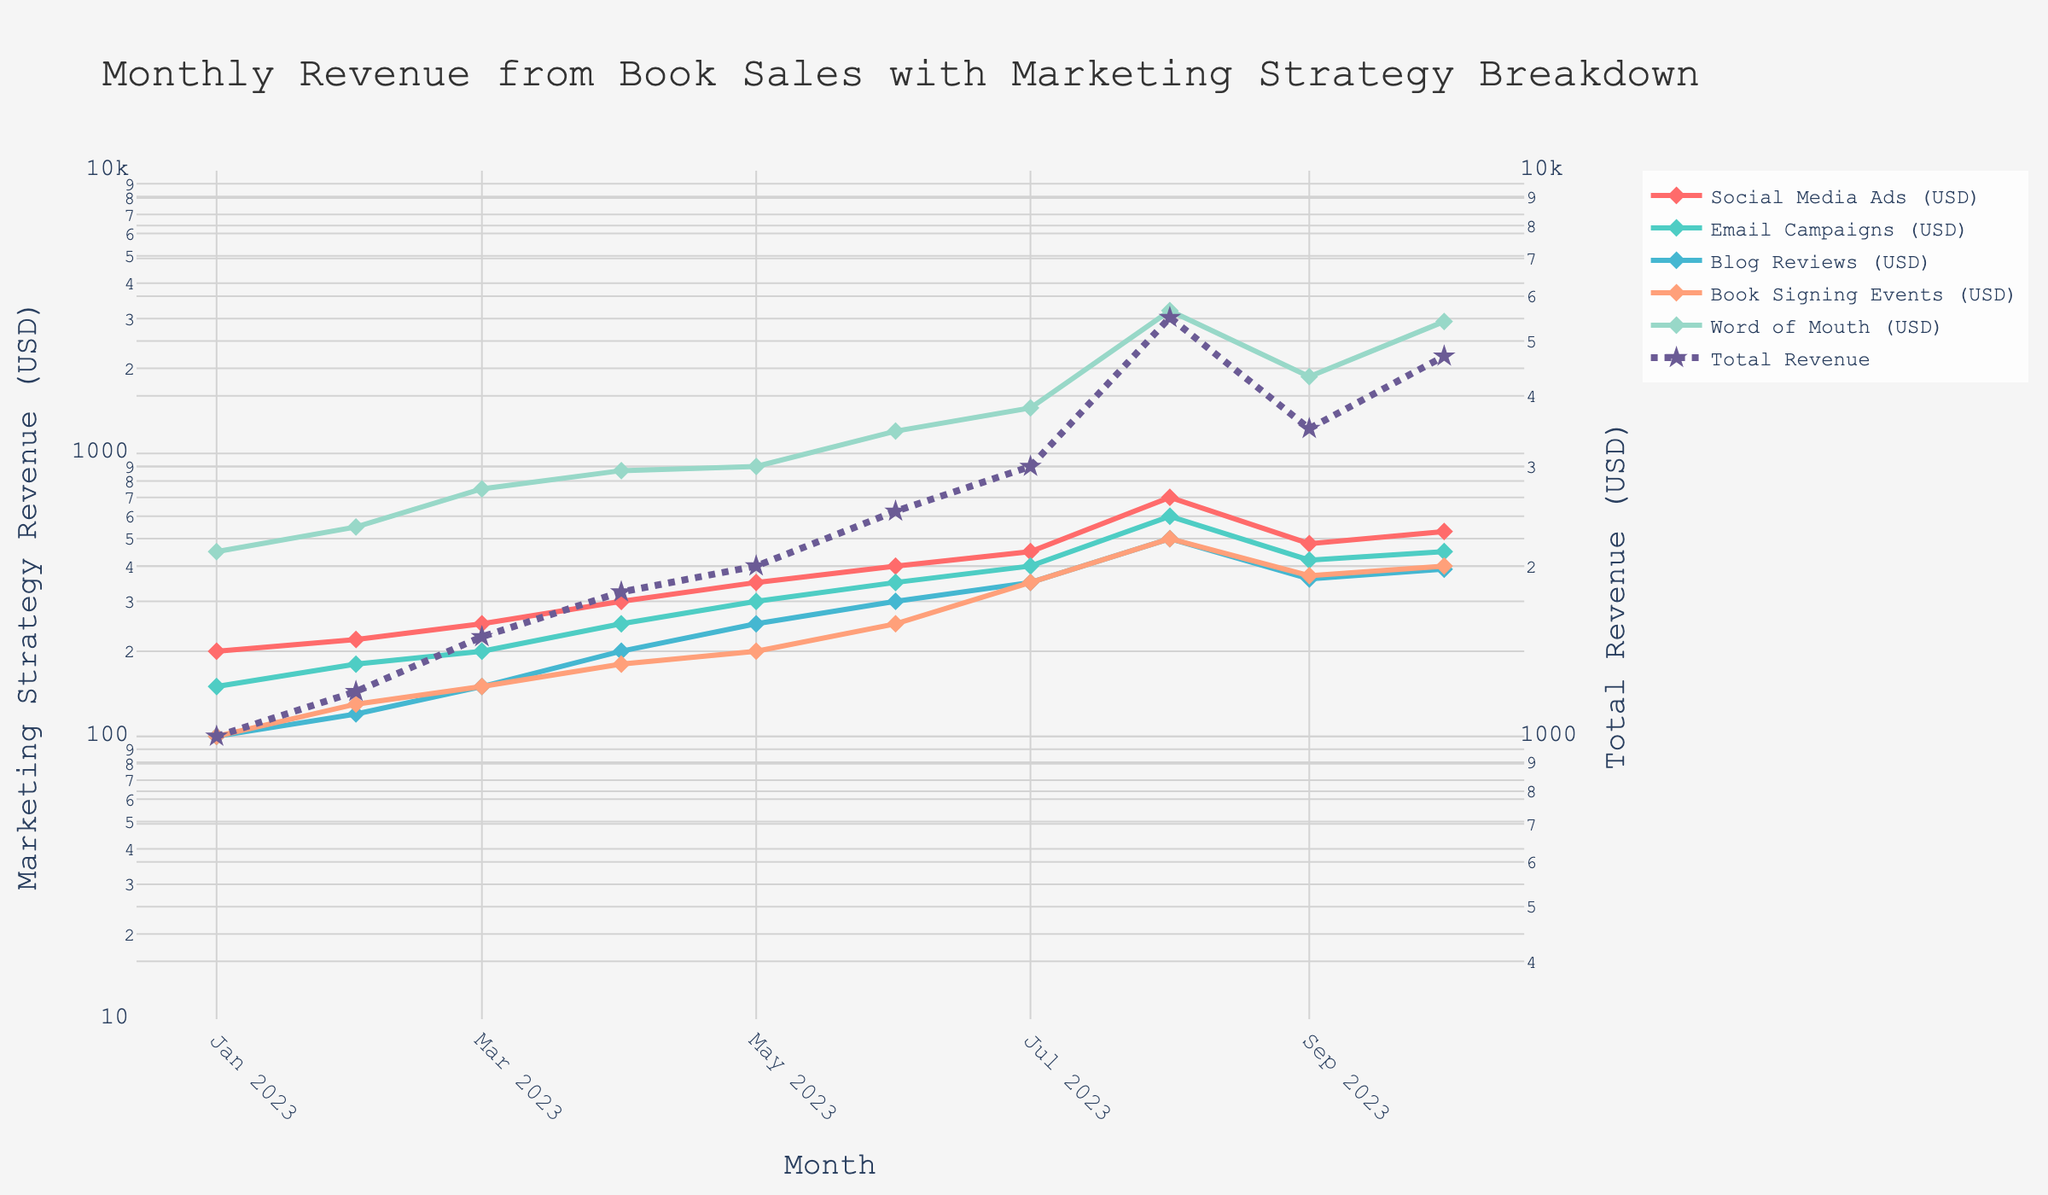what is the title of the figure? The title is presented at the top of the figure and provides a clear summary of the visualized data. The displayed title reads: "Monthly Revenue from Book Sales with Marketing Strategy Breakdown"
Answer: Monthly Revenue from Book Sales with Marketing Strategy Breakdown Which marketing strategy contributed the most in August 2023? Observing the plot for the month of August 2023, the line with the highest value pertains to the "Word of Mouth (USD)" strategy. This line reaches its peak compared to other strategies in the same month.
Answer: Word of Mouth What was the total revenue in July 2023? The line representing "Total Revenue" includes markers and corresponds to a secondary y-axis with a logarithmic scale. For July 2023, this line intersects the y-axis around the value of 3000 USD.
Answer: 3000 USD In which month did the total revenue see the highest value? Observing the "Total Revenue" line and the values on the right y-axis, we can see that the highest point occurs in August 2023, where the revenue reaches its peak.
Answer: August 2023 How did the revenue from Email Campaigns change from January 2023 to June 2023? Tracking the "Email Campaigns (USD)" line from January to June 2023 shows a steady increase, starting from 150 USD and gradually rising to 350 USD by June.
Answer: Increased steadily Which two marketing strategies have the closest values in September 2023? By examining the y-values of each strategy for September 2023, it is evident that "Social Media Ads (USD)" and "Email Campaigns (USD)" lines are closest to each other, with values near 480 USD and 420 USD respectively.
Answer: Social Media Ads and Email Campaigns How many months show a total revenue greater than 4000 USD? Checking the "Total Revenue" line against the log-scaled secondary y-axis reveals that only August and October 2023 exceed the 4000 USD mark.
Answer: 2 months Compare the revenue from Book Signing Events between April and May 2023. The "Book Signing Events (USD)" line for April 2023 intersects the y-axis around 200 USD, and for May 2023, it is around 250 USD. Therefore, the revenue increased by 50 USD from April to May 2023.
Answer: Increased by 50 USD Which month saw the highest growth in total revenue compared to the previous month? Observing the sharpest rise in the "Total Revenue" line, August 2023 depicts the most significant increase from the previous month. The revenue jumps noticeably higher compared to July 2023.
Answer: August 2023 What's the average monthly revenue from Blog Reviews over the period? Tracking the "Blog Reviews (USD)" line and summing the values from each month (100, 120, 150, 200, 250, 300, 350, 500, 360, 390), then dividing by the number of months (10), gives the average monthly revenue. The sum is 2720 USD, so the average is 272 USD.
Answer: 272 USD 